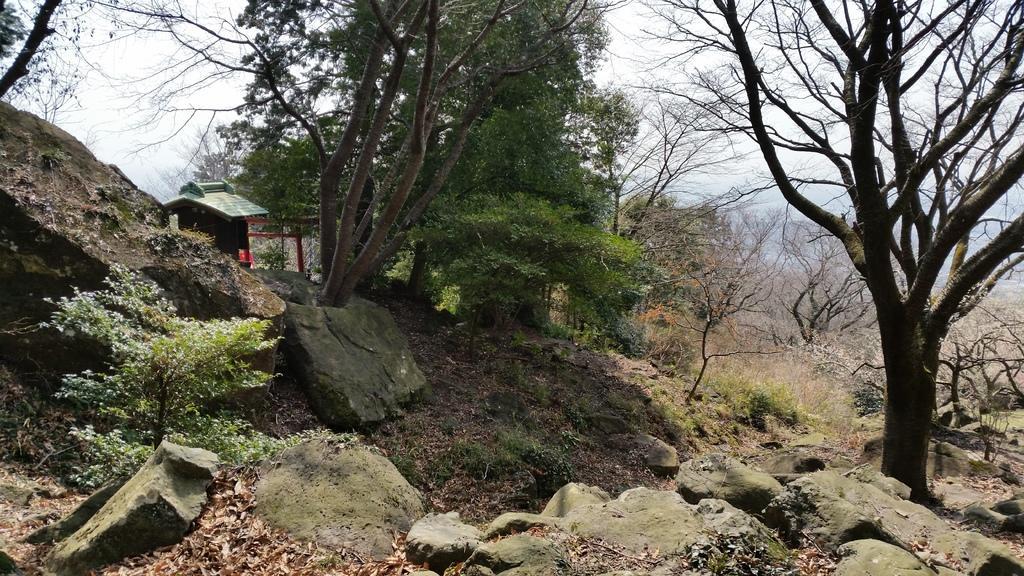Could you give a brief overview of what you see in this image? In this image I see the trees, rocks and the plants and I can also see the leaves on the ground. In the background I see the sky. 